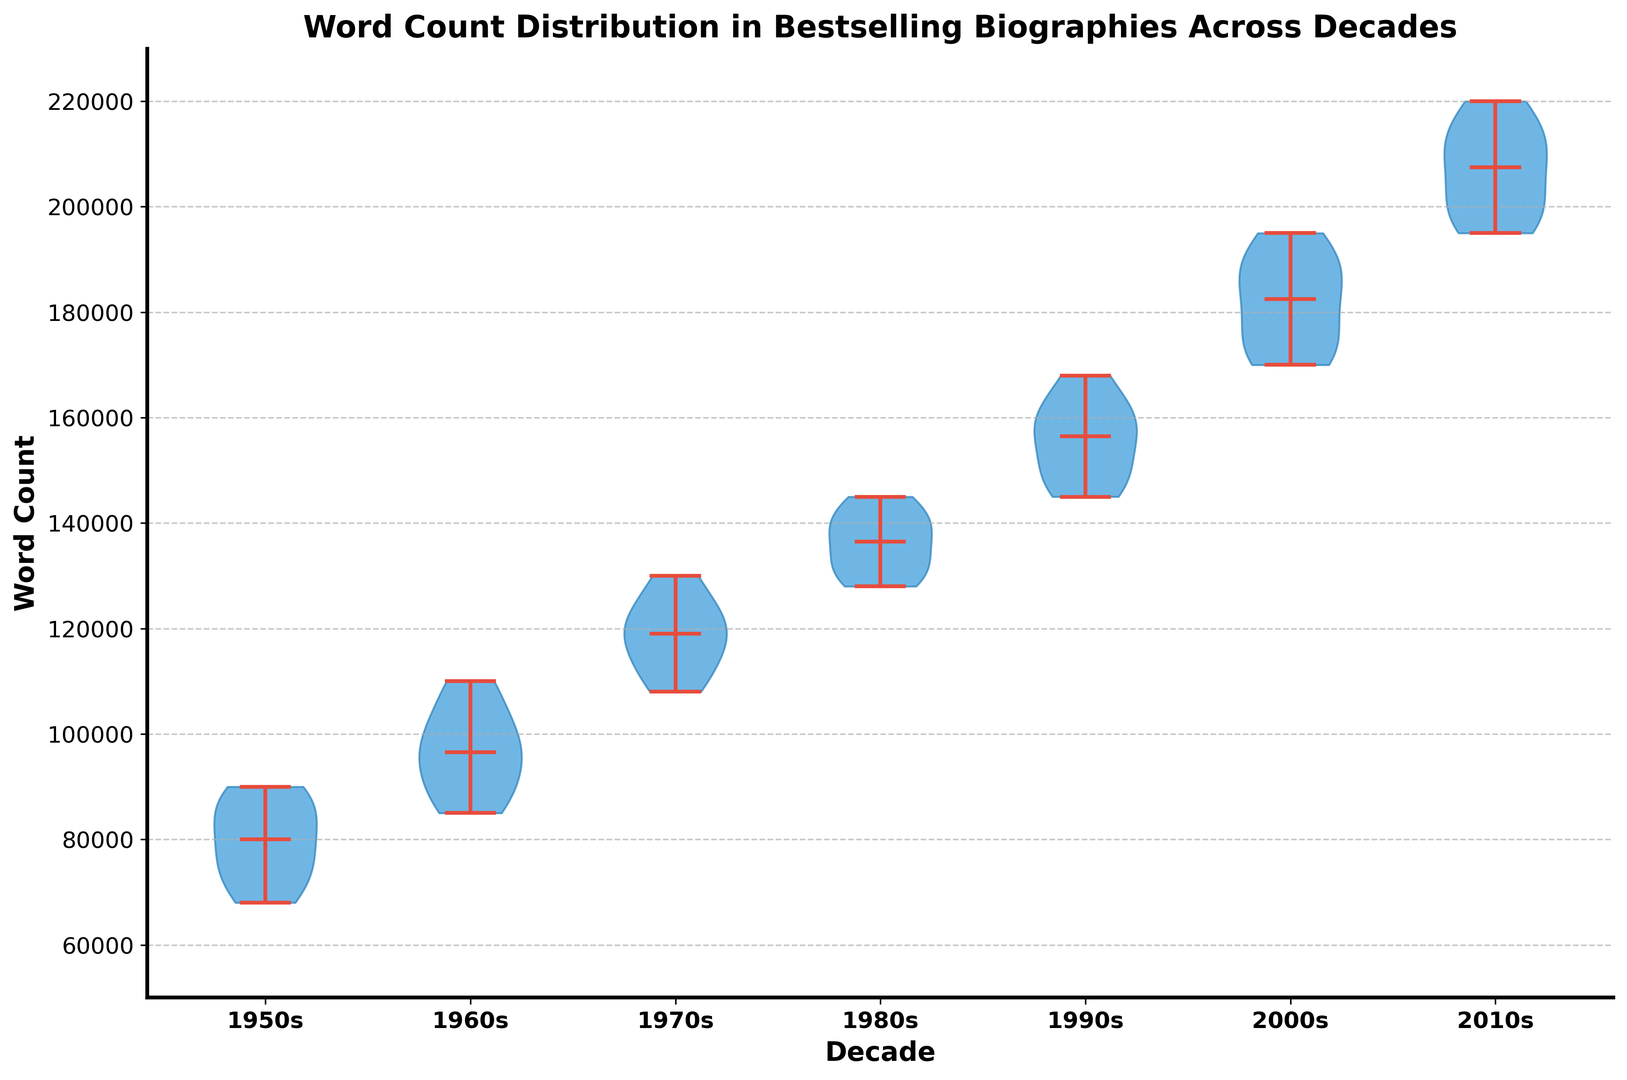What is the median word count of biographies in the 1970s? To find the median, look at the white line within the violin plot for the 1970s. The white line represents the median value for that decade.
Answer: 120000 Which decade shows the widest range of word counts for bestselling biographies? The range can be determined by looking at the vertical extent of each violin. The widest range is indicated by the tallest violin extending from top to bottom.
Answer: 2010s How does the median word count in the 1960s compare to the median word count in the 1980s? Locate the white median lines within the violins for both decades. Compare their heights vertically. The 1980s median is higher than the 1960s median.
Answer: The 1980s has a higher median word count What is the approximate increase in the median word count from the 1950s to the 2010s? Find the median values for both the 1950s and the 2010s (the white lines) and calculate the difference between them.
Answer: 125000 Are any decades showing a noticeable shift in the distribution of word counts compared to others? Look at the shapes of the violins. A noticeable shift would be indicated by a substantial change in the positions and spread of the violins across decades.
Answer: Yes, there is a noticeable upward shift from the 1950s to the 2010s In which decade is the median word count approximately around 105000? Identify the decade where the white median line is positioned near 105000. This is observed in the violin plot for the 1960s.
Answer: 1960s Which decade has the largest interquartile range (IQR) of word counts? The IQR can be assessed by the width of the violin at the middle 50% of data. The decade with the widest section in the middle indicates the largest IQR.
Answer: 2000s Is there a decade where the bestselling biographies' word counts are fairly uniform? Uniform distribution would appear relatively symmetrical and not too dispersed. Look for the decade with the most evenly shaped and narrow violin.
Answer: 1950s What visual difference indicates the variance in word counts between the 1980s and the 1990s? Compare the spread and shape of the violins. The 1990s violin is taller, indicating higher variability in word counts compared to the 1980s.
Answer: The 1990s have greater variance Which decades have overlapping word count distributions, as indicated by their violin plots? Overlapping distributions are visually indicated by violins that are near to each other with similar spreads and central regions.
Answer: 1980s and 1990s 